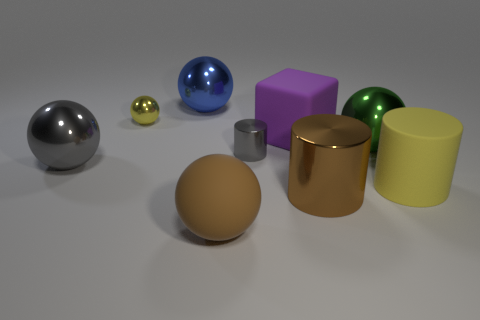There is a brown thing on the left side of the cylinder to the left of the large purple rubber object; what shape is it?
Keep it short and to the point. Sphere. There is a brown matte object; does it have the same shape as the gray shiny object left of the tiny gray metal object?
Give a very brief answer. Yes. There is a yellow thing that is on the left side of the big shiny cylinder; how many big things are in front of it?
Your answer should be compact. 6. What material is the big yellow object that is the same shape as the tiny gray object?
Give a very brief answer. Rubber. What number of cyan objects are either tiny objects or small shiny spheres?
Make the answer very short. 0. Is there anything else that has the same color as the matte cylinder?
Keep it short and to the point. Yes. What is the color of the sphere that is to the right of the big brown thing that is in front of the large metal cylinder?
Make the answer very short. Green. Is the number of matte balls that are right of the big brown sphere less than the number of matte things that are on the right side of the purple rubber block?
Your response must be concise. Yes. There is a big cylinder that is the same color as the tiny ball; what is it made of?
Ensure brevity in your answer.  Rubber. How many things are either cylinders that are left of the rubber cube or big blue metallic spheres?
Your answer should be very brief. 2. 